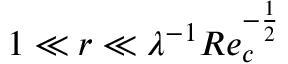Convert formula to latex. <formula><loc_0><loc_0><loc_500><loc_500>1 \ll r \ll \lambda ^ { - 1 } R e _ { c } ^ { - \frac { 1 } { 2 } }</formula> 